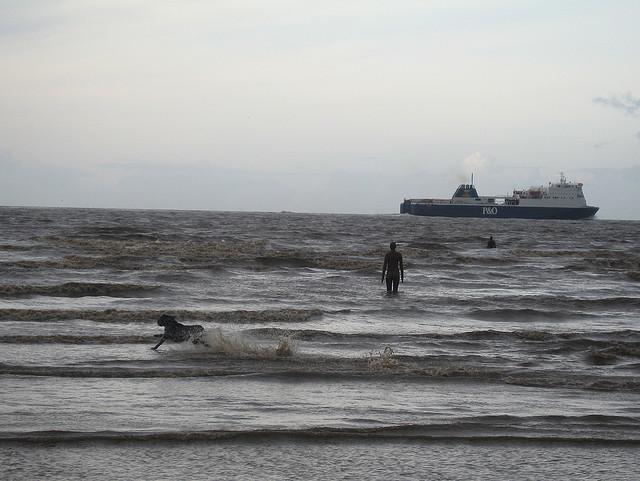Is the dog running?
Short answer required. Yes. What is in the background?
Concise answer only. Ship. Are the people in the middle of the ocean?
Give a very brief answer. Yes. What is the man standing on?
Keep it brief. Water. Is morning approaching?
Concise answer only. No. Is the person windsurfing?
Be succinct. No. Is the water calm or wavy?
Quick response, please. Wavy. What is the person doing in the water?
Keep it brief. Standing. What is the boat on the water carrying?
Keep it brief. Cargo. How many boats are there?
Be succinct. 1. How are the water conditions?
Concise answer only. Choppy. What are the boats for?
Answer briefly. Transportation. What is the large object in the background?
Write a very short answer. Ship. Is he sitting on a surfboard?
Give a very brief answer. No. Which is deeper, the ocean or the dog's love for its owner?
Short answer required. Ocean. Is it sunny?
Write a very short answer. No. What color is the water?
Write a very short answer. Gray. How many waves can be seen?
Keep it brief. 10. Is the water calm?
Keep it brief. No. 